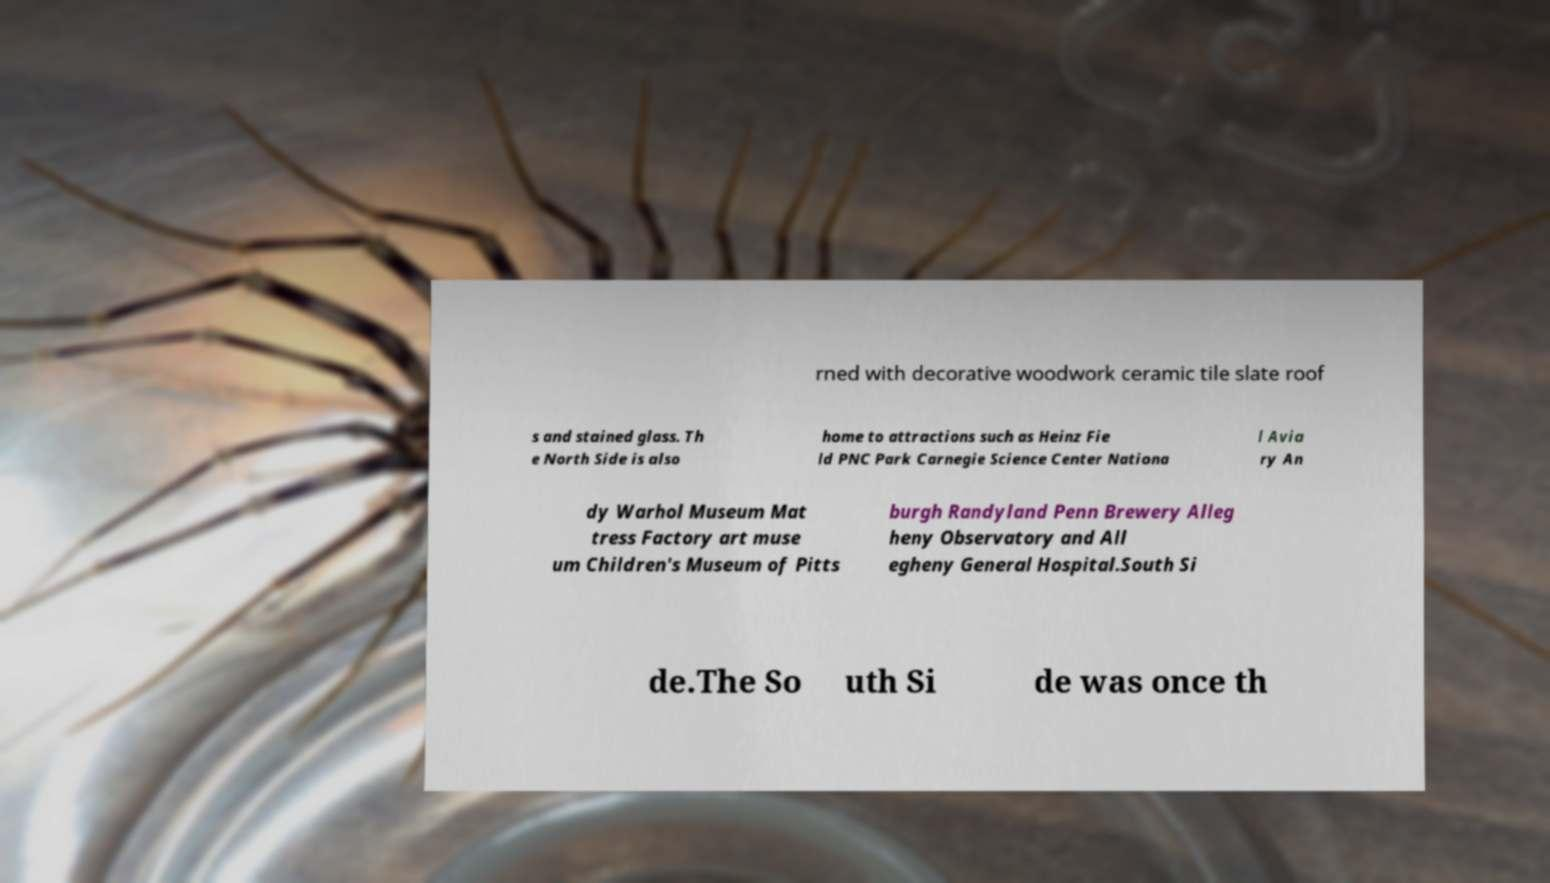Please read and relay the text visible in this image. What does it say? rned with decorative woodwork ceramic tile slate roof s and stained glass. Th e North Side is also home to attractions such as Heinz Fie ld PNC Park Carnegie Science Center Nationa l Avia ry An dy Warhol Museum Mat tress Factory art muse um Children's Museum of Pitts burgh Randyland Penn Brewery Alleg heny Observatory and All egheny General Hospital.South Si de.The So uth Si de was once th 